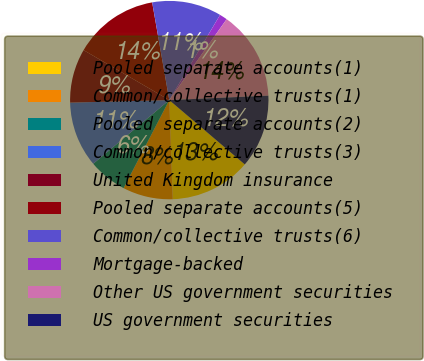<chart> <loc_0><loc_0><loc_500><loc_500><pie_chart><fcel>Pooled separate accounts(1)<fcel>Common/collective trusts(1)<fcel>Pooled separate accounts(2)<fcel>Common/collective trusts(3)<fcel>United Kingdom insurance<fcel>Pooled separate accounts(5)<fcel>Common/collective trusts(6)<fcel>Mortgage-backed<fcel>Other US government securities<fcel>US government securities<nl><fcel>13.21%<fcel>8.18%<fcel>6.29%<fcel>10.69%<fcel>8.81%<fcel>13.84%<fcel>11.32%<fcel>1.26%<fcel>14.47%<fcel>11.95%<nl></chart> 